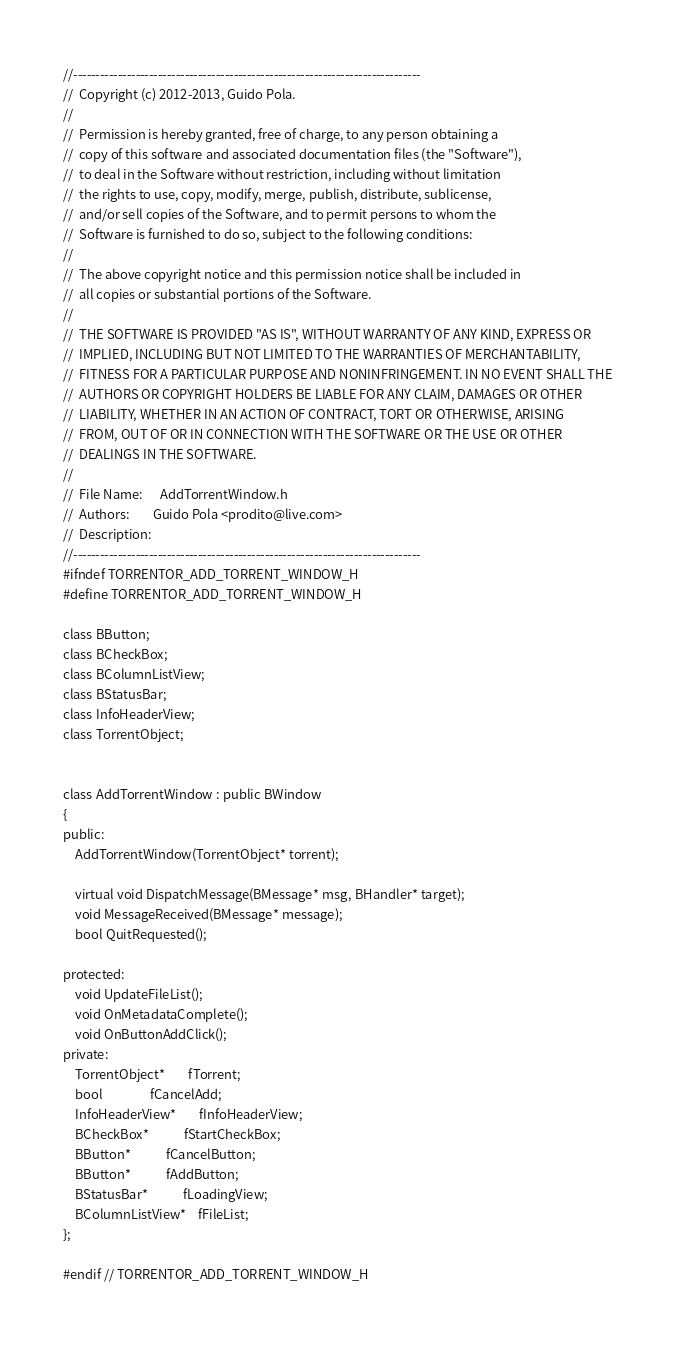Convert code to text. <code><loc_0><loc_0><loc_500><loc_500><_C_>//------------------------------------------------------------------------------
//	Copyright (c) 2012-2013, Guido Pola.
//
//	Permission is hereby granted, free of charge, to any person obtaining a
//	copy of this software and associated documentation files (the "Software"),
//	to deal in the Software without restriction, including without limitation
//	the rights to use, copy, modify, merge, publish, distribute, sublicense,
//	and/or sell copies of the Software, and to permit persons to whom the
//	Software is furnished to do so, subject to the following conditions:
//
//	The above copyright notice and this permission notice shall be included in
//	all copies or substantial portions of the Software.
//
//	THE SOFTWARE IS PROVIDED "AS IS", WITHOUT WARRANTY OF ANY KIND, EXPRESS OR
//	IMPLIED, INCLUDING BUT NOT LIMITED TO THE WARRANTIES OF MERCHANTABILITY,
//	FITNESS FOR A PARTICULAR PURPOSE AND NONINFRINGEMENT. IN NO EVENT SHALL THE
//	AUTHORS OR COPYRIGHT HOLDERS BE LIABLE FOR ANY CLAIM, DAMAGES OR OTHER
//	LIABILITY, WHETHER IN AN ACTION OF CONTRACT, TORT OR OTHERWISE, ARISING
//	FROM, OUT OF OR IN CONNECTION WITH THE SOFTWARE OR THE USE OR OTHER
//	DEALINGS IN THE SOFTWARE.
//
//	File Name:		AddTorrentWindow.h
//	Authors:		Guido Pola <prodito@live.com>
//	Description:	
//------------------------------------------------------------------------------
#ifndef TORRENTOR_ADD_TORRENT_WINDOW_H
#define TORRENTOR_ADD_TORRENT_WINDOW_H

class BButton;
class BCheckBox;
class BColumnListView;
class BStatusBar;
class InfoHeaderView;
class TorrentObject;


class AddTorrentWindow : public BWindow
{
public:
	AddTorrentWindow(TorrentObject* torrent);
	
	virtual void DispatchMessage(BMessage* msg, BHandler* target);
	void MessageReceived(BMessage* message);
	bool QuitRequested();

protected:
	void UpdateFileList();
	void OnMetadataComplete();
	void OnButtonAddClick();
private:
	TorrentObject*		fTorrent;
	bool				fCancelAdd;
	InfoHeaderView*		fInfoHeaderView;
	BCheckBox*			fStartCheckBox;
	BButton*			fCancelButton;
	BButton*			fAddButton;
	BStatusBar*			fLoadingView;
	BColumnListView*	fFileList;
};

#endif // TORRENTOR_ADD_TORRENT_WINDOW_H
</code> 